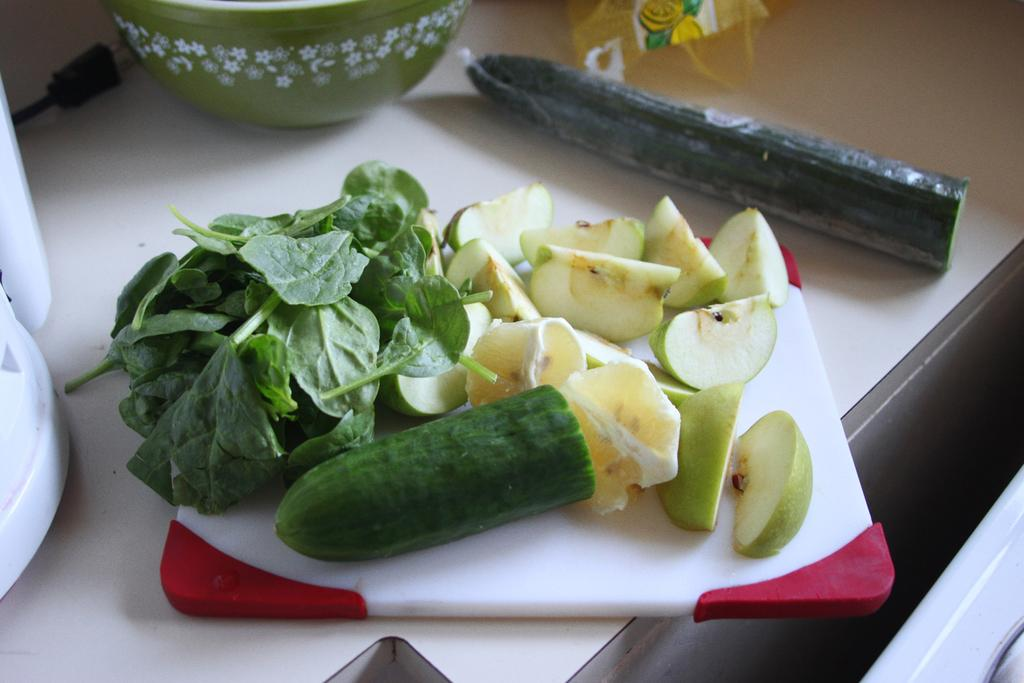What is in the bowl that is visible in the image? There are fruits in the image. What other types of food can be seen in the image? There are vegetables in the image. What surface is used for cutting in the image? There is a cutting pad in the image. What is present on the table in the image? There are objects on the table in the image. How many friends are sitting around the table in the image? There are no friends present in the image; it only shows a bowl, fruits, vegetables, a cutting pad, and objects on the table. What type of oranges can be seen in the image? There are no oranges present in the image. 